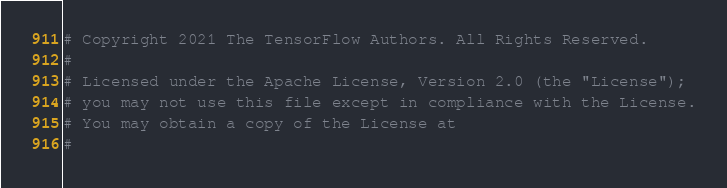<code> <loc_0><loc_0><loc_500><loc_500><_Python_># Copyright 2021 The TensorFlow Authors. All Rights Reserved.
#
# Licensed under the Apache License, Version 2.0 (the "License");
# you may not use this file except in compliance with the License.
# You may obtain a copy of the License at
#</code> 